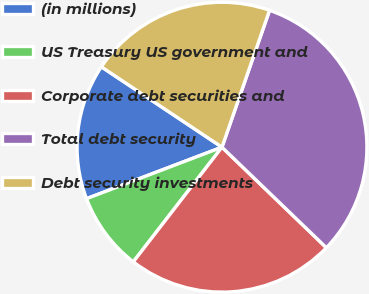Convert chart to OTSL. <chart><loc_0><loc_0><loc_500><loc_500><pie_chart><fcel>(in millions)<fcel>US Treasury US government and<fcel>Corporate debt securities and<fcel>Total debt security<fcel>Debt security investments<nl><fcel>15.14%<fcel>8.74%<fcel>23.28%<fcel>31.88%<fcel>20.97%<nl></chart> 